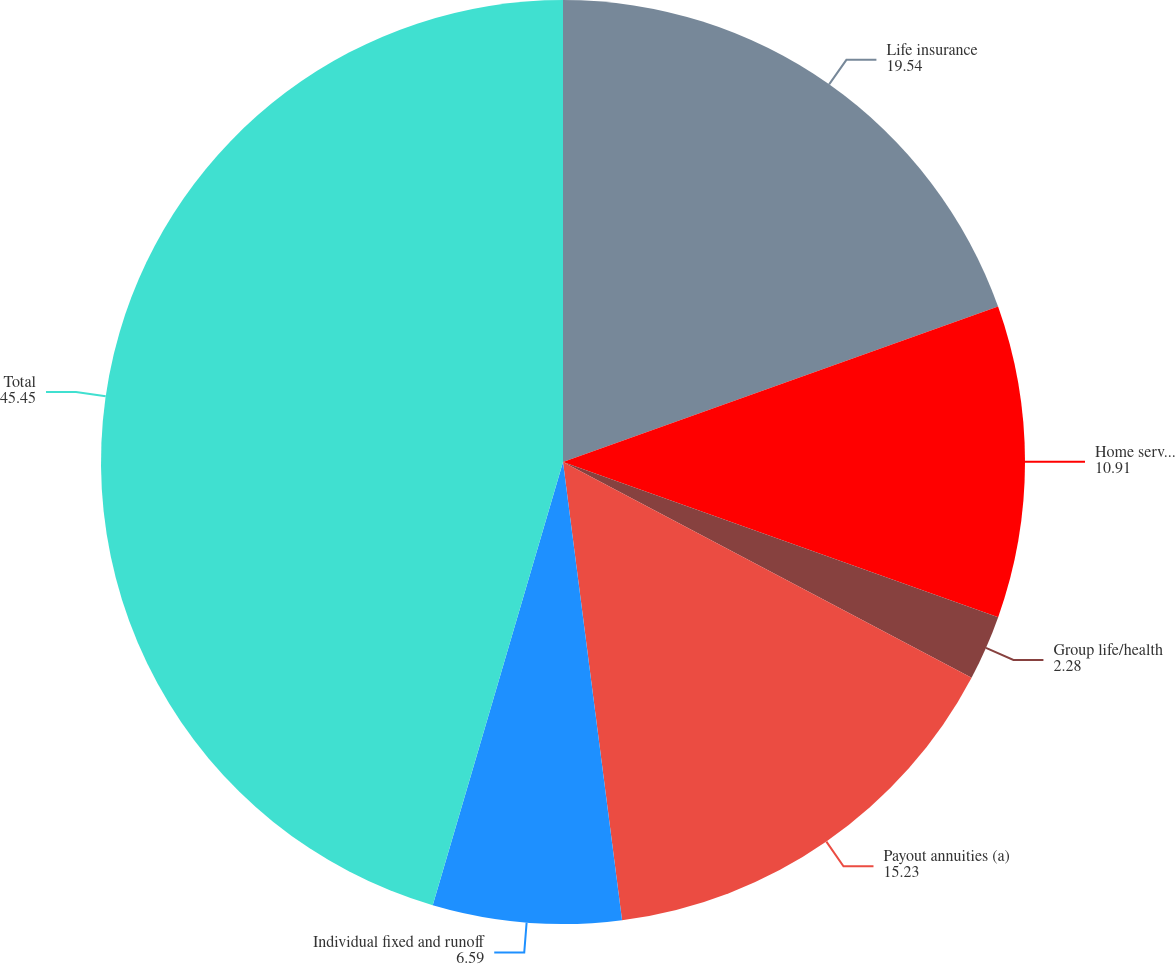<chart> <loc_0><loc_0><loc_500><loc_500><pie_chart><fcel>Life insurance<fcel>Home service<fcel>Group life/health<fcel>Payout annuities (a)<fcel>Individual fixed and runoff<fcel>Total<nl><fcel>19.54%<fcel>10.91%<fcel>2.28%<fcel>15.23%<fcel>6.59%<fcel>45.45%<nl></chart> 